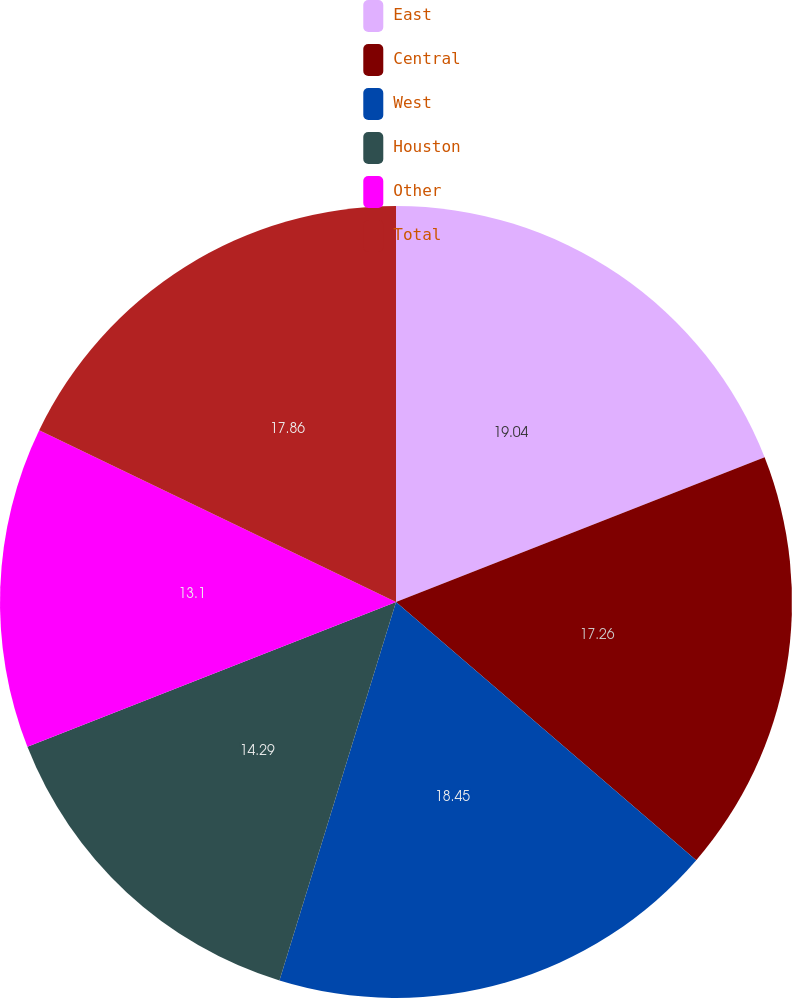Convert chart. <chart><loc_0><loc_0><loc_500><loc_500><pie_chart><fcel>East<fcel>Central<fcel>West<fcel>Houston<fcel>Other<fcel>Total<nl><fcel>19.05%<fcel>17.26%<fcel>18.45%<fcel>14.29%<fcel>13.1%<fcel>17.86%<nl></chart> 